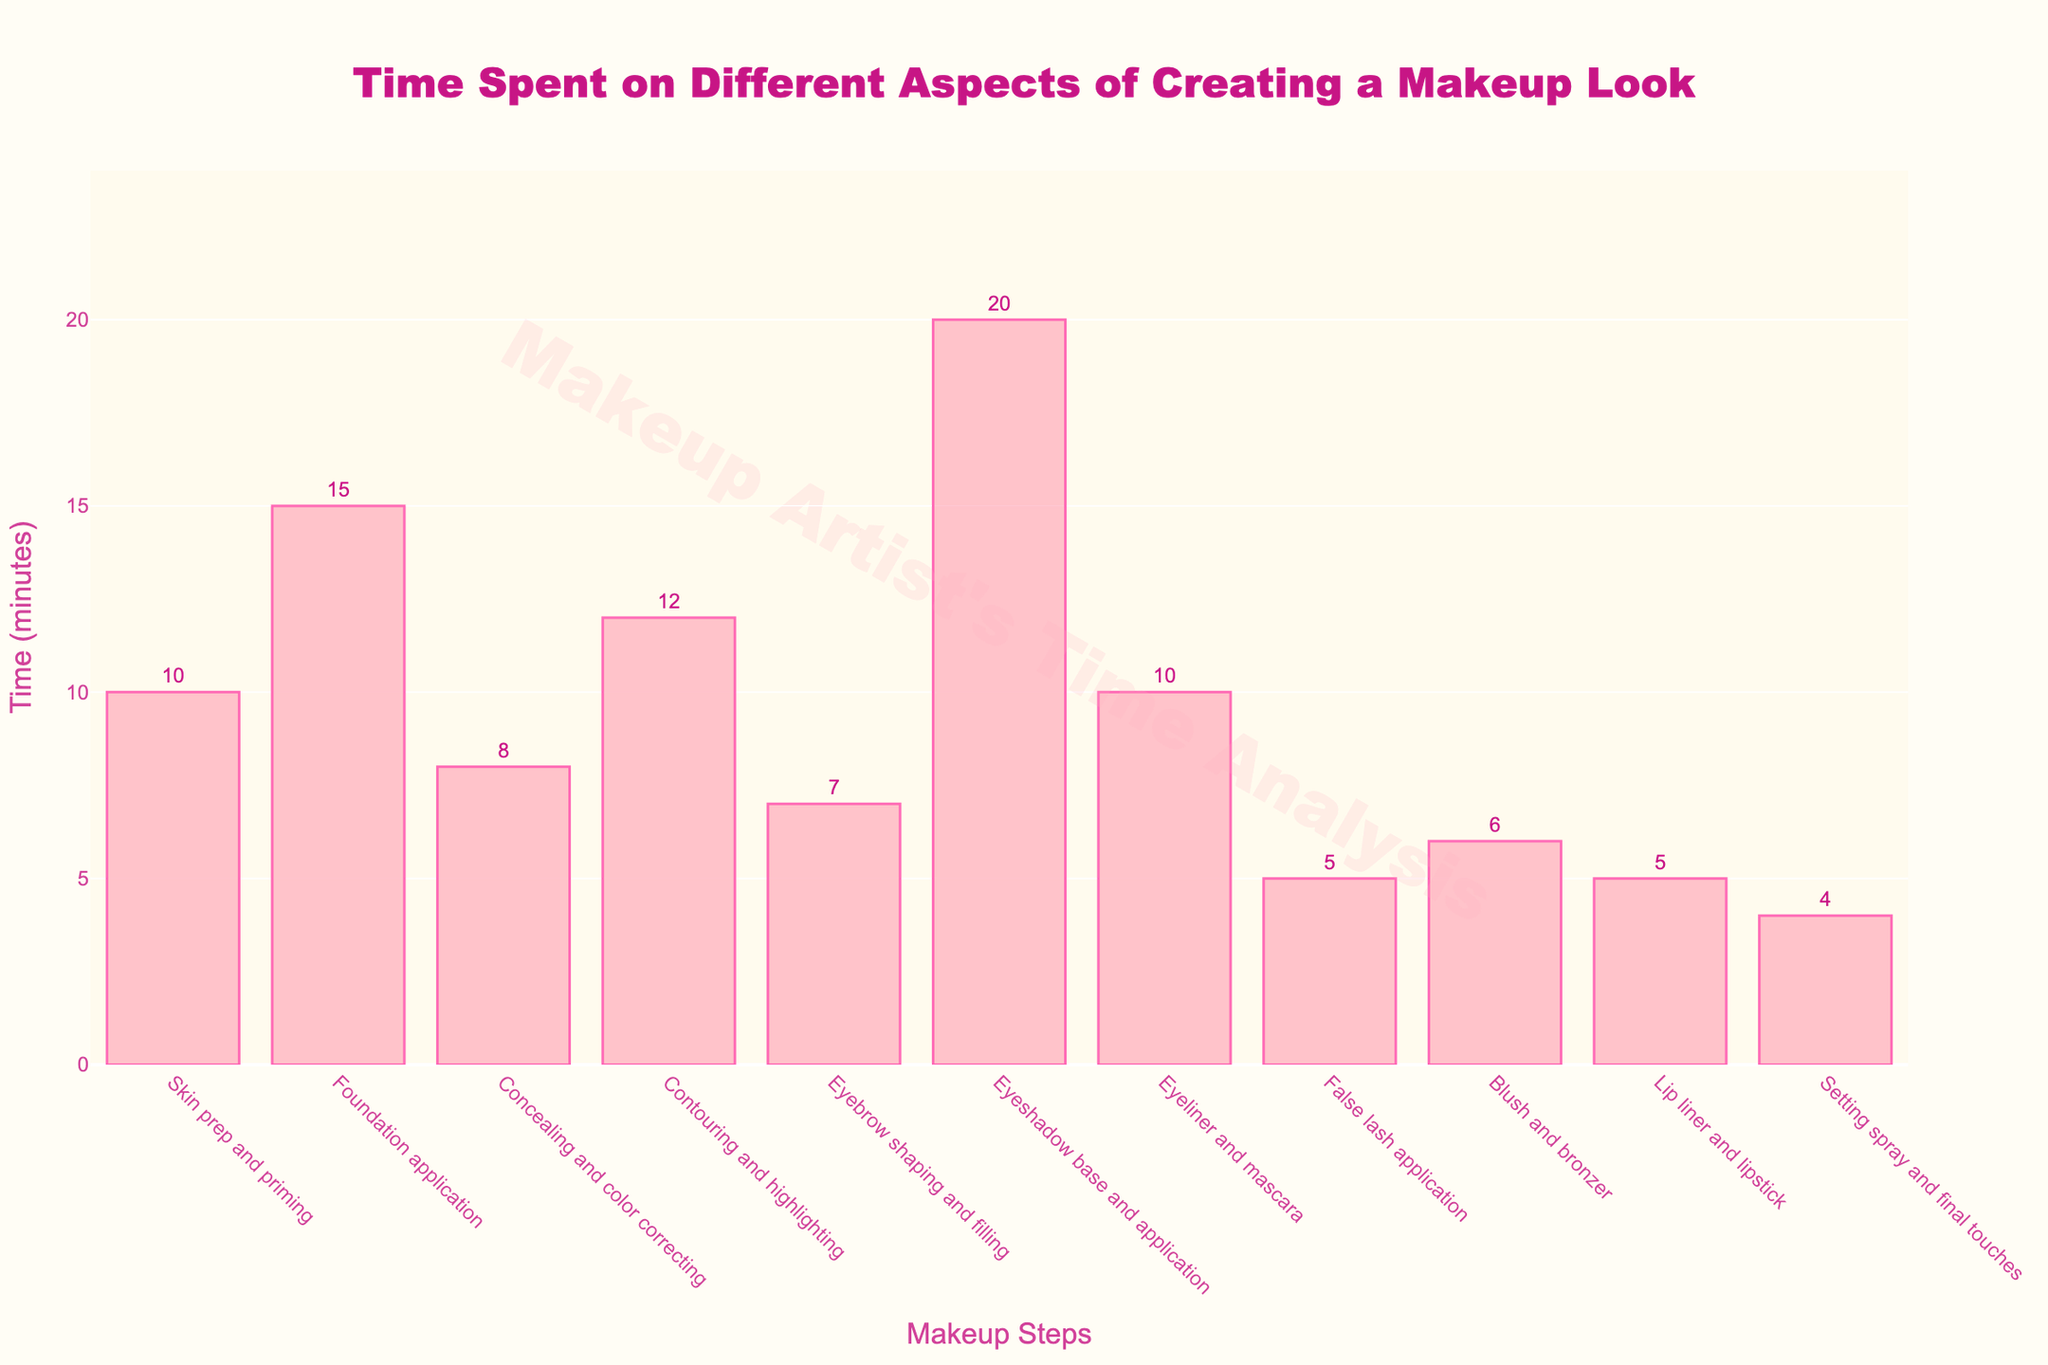Which step takes the most time? Eyebrow shaping and filling takes 7 minutes, and foundation application takes 15 minutes. So, foundation application takes the most time.
Answer: Foundation application Which step takes the least time? Lip liner and lipstick, as well as false lash application, both take 5 minutes, which are the shortest in terms of time spent.
Answer: False lash application and Lip liner and lipstick How much time is spent on skin prep and primer compared to setting spray and final touches? Skin prep and priming takes 10 minutes while setting spray and final touches take 4 minutes. The difference is 10 - 4 = 6 minutes.
Answer: 6 minutes more on skin prep and priming What is the total time spent on contouring, highlighting, and blush and bronzer? Contouring and highlighting takes 12 minutes and blush and bronzer takes 6 minutes. Their sum is 12 + 6 = 18 minutes.
Answer: 18 minutes Do eyeliners and mascara take more time than false lash application? Eyeliner and mascara take 10 minutes, while false lash application takes 5 minutes. 10 minutes is indeed greater than 5 minutes.
Answer: Yes What is the average time spent on skin prep and priming, foundation application, and concealing and color correcting? The times are 10 minutes, 15 minutes, and 8 minutes respectively. Their average is (10 + 15 + 8) / 3 = 33 / 3 = 11 minutes.
Answer: 11 minutes Which step takes twice the time of blending and bronzing? Blush and bronzer take 6 minutes. Twice this time is 6 * 2 = 12 minutes, which is the time taken by contouring and highlighting.
Answer: Contouring and highlighting What is the difference in time between the longest and shortest steps? The longest step, eyeshadow base and application, takes 20 minutes and the shortest step, setting spray and final touches, takes 4 minutes. The difference is 20 - 4 = 16 minutes.
Answer: 16 minutes What percentage of the total time is spent on eyeshadow base and application? Total time spent is 102 minutes. Time on eyeshadow base and application is 20 minutes. The percentage is (20 / 102) * 100 ≈ 19.61%.
Answer: Approximately 19.61% How does the time spent on foundation application compare to contouring and highlighting? Foundation application is 15 minutes while contouring and highlighting is 12 minutes. 15 minutes is more than 12 minutes by 3.
Answer: 3 minutes more on foundation application 